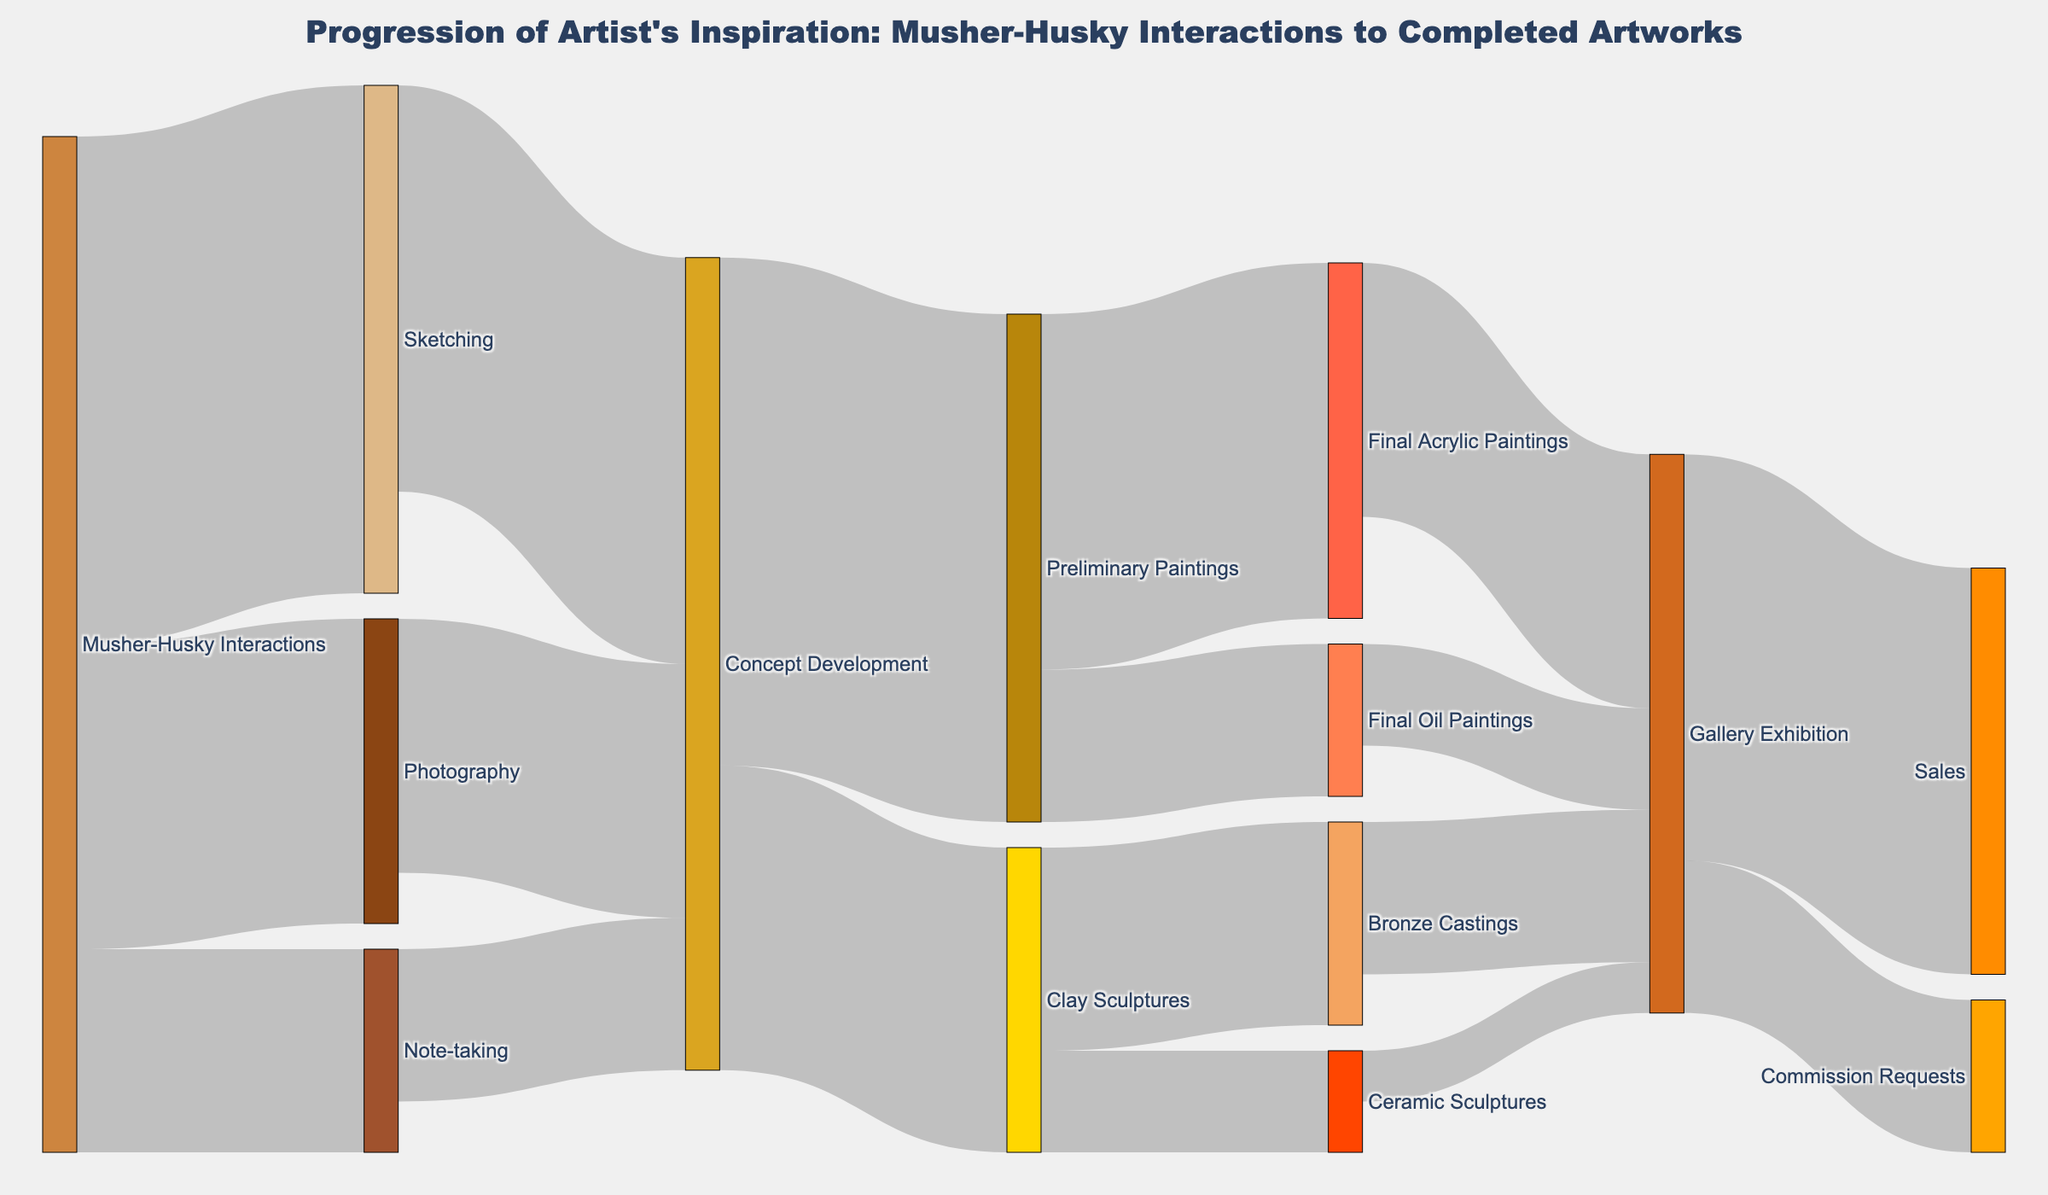what is the title of the Sankey diagram? The title of the Sankey diagram is typically found at the top of the chart and provides a summary of what the diagram represents. In this plot, it is denoted above the visual elements.
Answer: Progression of Artist's Inspiration: Musher-Husky Interactions to Completed Artworks What different initial sources of inspiration are indicated in the diagram? The initial sources of inspiration are typically found on the leftmost side of a Sankey diagram. These nodes should have arrows or links extending to several different targets.
Answer: Musher-Husky Interactions How many artworks progress from Concept Development to Preliminary Paintings and Clay Sculptures combined? To find this, look at the links extending from Concept Development to both Preliminary Paintings and Clay Sculptures, then add the values of these links together. The link values are 50 and 30, respectively.
Answer: 80 Which stage has the highest number of artworks leading into the Gallery Exhibition? Check the target node "Gallery Exhibition" and compare the values of all incoming links to see which one is the highest. The incoming links from Final Acrylic Paintings, Final Oil Paintings, Bronze Castings, and Ceramic Sculptures have values of 25, 10, 15, and 5, respectively.
Answer: Final Acrylic Paintings What is the total number of artworks related to Preliminary Paintings and the stages it progresses to? First, find the value leading to Preliminary Paintings from Concept Development, which is 50. Then, add the values of all the outgoing links from Preliminary Paintings to Final Acrylic Paintings (35) and Final Oil Paintings (15). The values sum up to 50.
Answer: 50 How do the number of artworks in Ceramic Sculptures compare to Bronze Castings? Look at the outgoing links from Clay Sculptures to see the values leading to Ceramic Sculptures and Bronze Castings. The values are 10 and 20, respectively, then compare them directly.
Answer: Bronze Castings have double the number of artworks as Ceramic Sculptures What is the total value of Commission Requests at the end of the progression? Identify the link leading to the target "Commission Requests" and note its value.
Answer: 15 Which two sources contribute to Concept Development from Musher-Husky Interactions, and what is their combined value? Look at the links starting from Musher-Husky Interactions and extending to Concept Development and sum their values. The relevant links are from Sketching and Photography with values 40 and 25, respectively.
Answer: 65 How many artworks progress from Preliminary Paintings to Final Oil Paintings? Find the link connecting Preliminary Paintings to Final Oil Paintings and note its value.
Answer: 15 